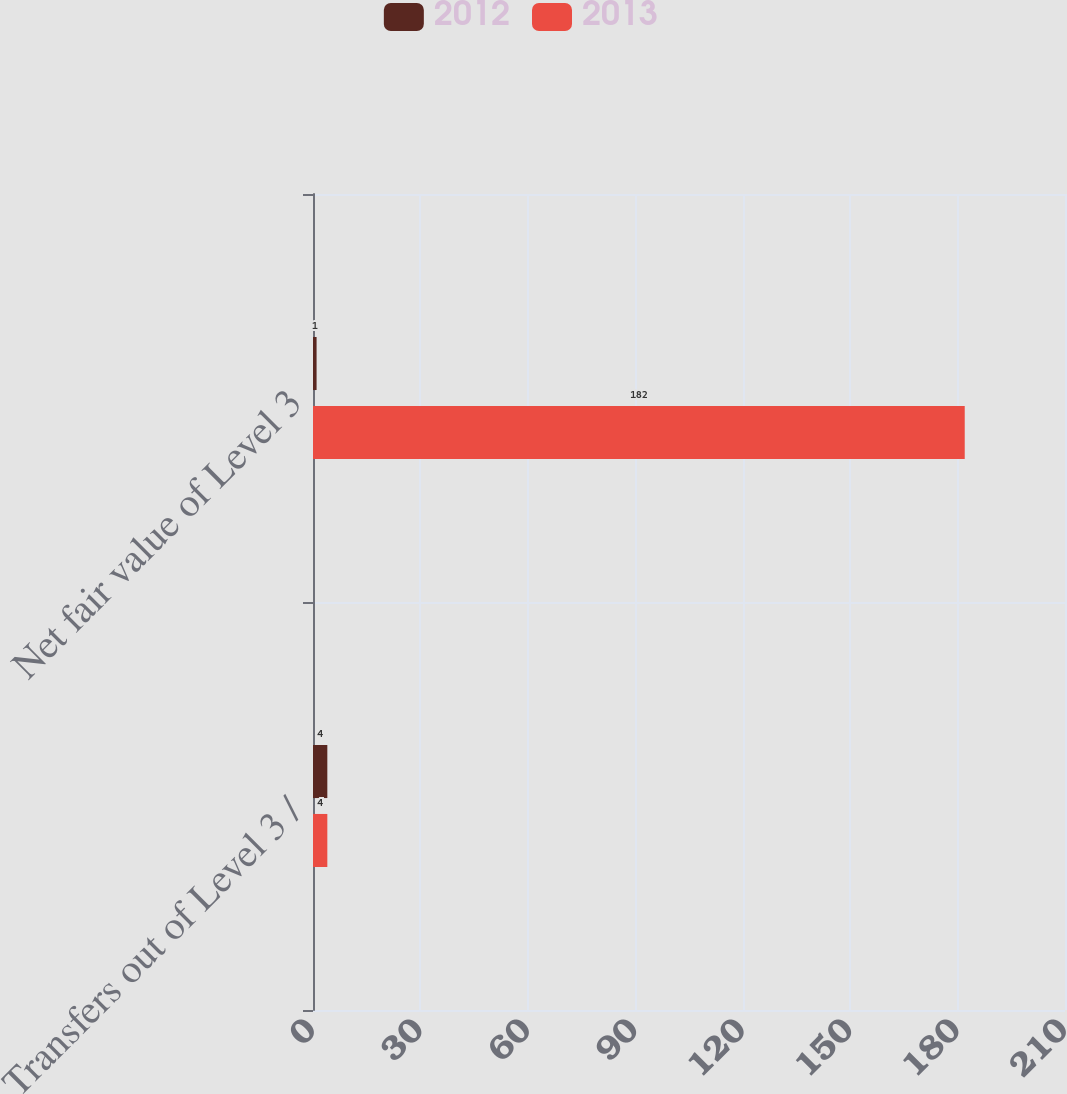<chart> <loc_0><loc_0><loc_500><loc_500><stacked_bar_chart><ecel><fcel>Transfers out of Level 3 /<fcel>Net fair value of Level 3<nl><fcel>2012<fcel>4<fcel>1<nl><fcel>2013<fcel>4<fcel>182<nl></chart> 